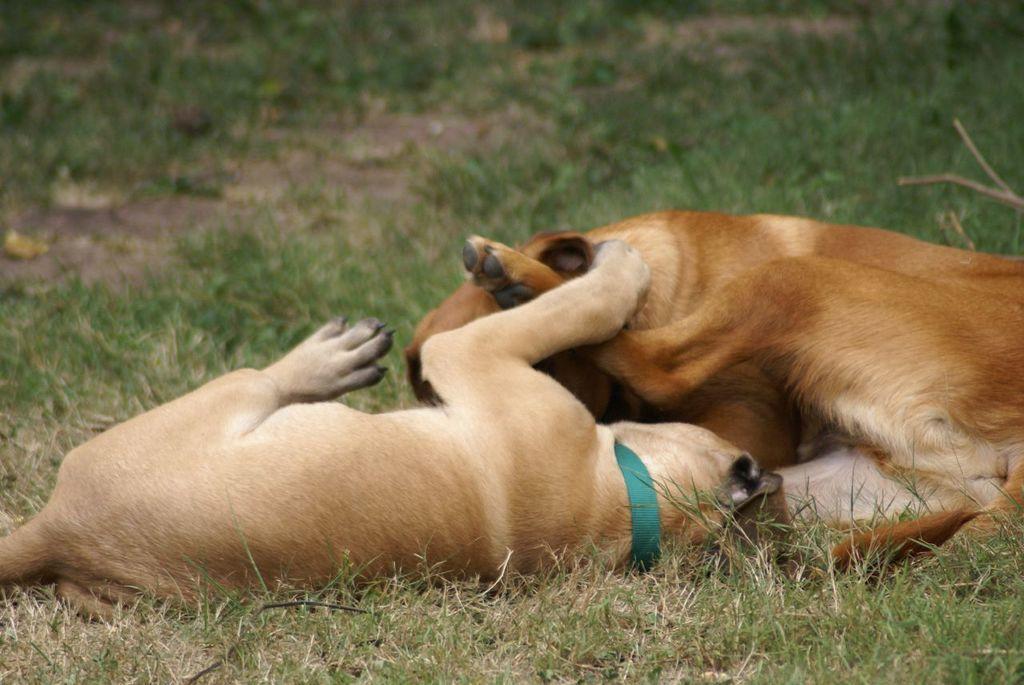Could you give a brief overview of what you see in this image? In the image there are two dogs lying on the ground. And on the ground there is grass. 